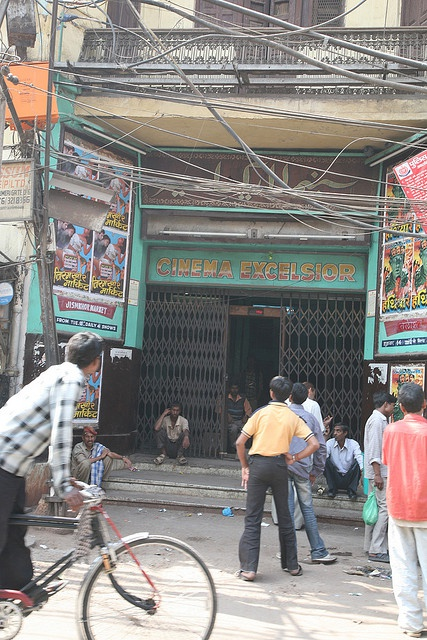Describe the objects in this image and their specific colors. I can see bicycle in lightgray, white, darkgray, and gray tones, people in lightgray, white, black, darkgray, and gray tones, people in lightgray, salmon, and gray tones, people in lightgray, gray, tan, black, and beige tones, and people in lightgray, darkgray, lavender, gray, and lightblue tones in this image. 